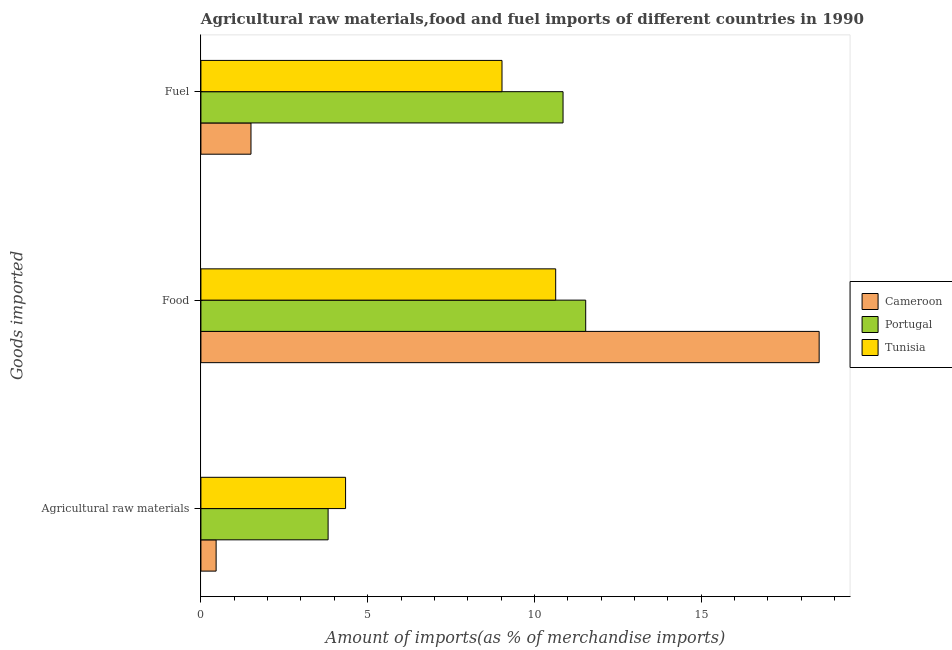How many different coloured bars are there?
Your answer should be very brief. 3. How many bars are there on the 3rd tick from the top?
Give a very brief answer. 3. How many bars are there on the 3rd tick from the bottom?
Keep it short and to the point. 3. What is the label of the 1st group of bars from the top?
Offer a terse response. Fuel. What is the percentage of fuel imports in Tunisia?
Ensure brevity in your answer.  9.03. Across all countries, what is the maximum percentage of food imports?
Make the answer very short. 18.54. Across all countries, what is the minimum percentage of raw materials imports?
Your answer should be very brief. 0.46. In which country was the percentage of raw materials imports maximum?
Your answer should be very brief. Tunisia. In which country was the percentage of raw materials imports minimum?
Provide a short and direct response. Cameroon. What is the total percentage of raw materials imports in the graph?
Your response must be concise. 8.61. What is the difference between the percentage of raw materials imports in Tunisia and that in Cameroon?
Offer a terse response. 3.88. What is the difference between the percentage of food imports in Cameroon and the percentage of fuel imports in Tunisia?
Your answer should be very brief. 9.51. What is the average percentage of fuel imports per country?
Provide a short and direct response. 7.13. What is the difference between the percentage of raw materials imports and percentage of food imports in Cameroon?
Ensure brevity in your answer.  -18.08. What is the ratio of the percentage of raw materials imports in Cameroon to that in Tunisia?
Keep it short and to the point. 0.11. Is the percentage of fuel imports in Portugal less than that in Tunisia?
Provide a succinct answer. No. Is the difference between the percentage of food imports in Portugal and Tunisia greater than the difference between the percentage of raw materials imports in Portugal and Tunisia?
Give a very brief answer. Yes. What is the difference between the highest and the second highest percentage of raw materials imports?
Your answer should be compact. 0.52. What is the difference between the highest and the lowest percentage of food imports?
Make the answer very short. 7.9. In how many countries, is the percentage of food imports greater than the average percentage of food imports taken over all countries?
Offer a very short reply. 1. What does the 2nd bar from the top in Agricultural raw materials represents?
Offer a very short reply. Portugal. What does the 1st bar from the bottom in Food represents?
Offer a very short reply. Cameroon. Is it the case that in every country, the sum of the percentage of raw materials imports and percentage of food imports is greater than the percentage of fuel imports?
Your answer should be very brief. Yes. Are all the bars in the graph horizontal?
Provide a succinct answer. Yes. What is the difference between two consecutive major ticks on the X-axis?
Offer a very short reply. 5. Does the graph contain any zero values?
Make the answer very short. No. Does the graph contain grids?
Offer a terse response. No. How many legend labels are there?
Ensure brevity in your answer.  3. How are the legend labels stacked?
Make the answer very short. Vertical. What is the title of the graph?
Your answer should be compact. Agricultural raw materials,food and fuel imports of different countries in 1990. Does "Rwanda" appear as one of the legend labels in the graph?
Give a very brief answer. No. What is the label or title of the X-axis?
Ensure brevity in your answer.  Amount of imports(as % of merchandise imports). What is the label or title of the Y-axis?
Offer a terse response. Goods imported. What is the Amount of imports(as % of merchandise imports) of Cameroon in Agricultural raw materials?
Your answer should be very brief. 0.46. What is the Amount of imports(as % of merchandise imports) in Portugal in Agricultural raw materials?
Provide a short and direct response. 3.81. What is the Amount of imports(as % of merchandise imports) of Tunisia in Agricultural raw materials?
Offer a very short reply. 4.34. What is the Amount of imports(as % of merchandise imports) of Cameroon in Food?
Keep it short and to the point. 18.54. What is the Amount of imports(as % of merchandise imports) of Portugal in Food?
Give a very brief answer. 11.54. What is the Amount of imports(as % of merchandise imports) of Tunisia in Food?
Offer a very short reply. 10.64. What is the Amount of imports(as % of merchandise imports) of Cameroon in Fuel?
Ensure brevity in your answer.  1.5. What is the Amount of imports(as % of merchandise imports) of Portugal in Fuel?
Keep it short and to the point. 10.86. What is the Amount of imports(as % of merchandise imports) of Tunisia in Fuel?
Make the answer very short. 9.03. Across all Goods imported, what is the maximum Amount of imports(as % of merchandise imports) in Cameroon?
Offer a terse response. 18.54. Across all Goods imported, what is the maximum Amount of imports(as % of merchandise imports) in Portugal?
Provide a succinct answer. 11.54. Across all Goods imported, what is the maximum Amount of imports(as % of merchandise imports) of Tunisia?
Offer a very short reply. 10.64. Across all Goods imported, what is the minimum Amount of imports(as % of merchandise imports) of Cameroon?
Your answer should be very brief. 0.46. Across all Goods imported, what is the minimum Amount of imports(as % of merchandise imports) in Portugal?
Your response must be concise. 3.81. Across all Goods imported, what is the minimum Amount of imports(as % of merchandise imports) in Tunisia?
Ensure brevity in your answer.  4.34. What is the total Amount of imports(as % of merchandise imports) in Cameroon in the graph?
Ensure brevity in your answer.  20.49. What is the total Amount of imports(as % of merchandise imports) in Portugal in the graph?
Make the answer very short. 26.21. What is the total Amount of imports(as % of merchandise imports) of Tunisia in the graph?
Offer a terse response. 24. What is the difference between the Amount of imports(as % of merchandise imports) in Cameroon in Agricultural raw materials and that in Food?
Ensure brevity in your answer.  -18.08. What is the difference between the Amount of imports(as % of merchandise imports) in Portugal in Agricultural raw materials and that in Food?
Provide a short and direct response. -7.72. What is the difference between the Amount of imports(as % of merchandise imports) of Tunisia in Agricultural raw materials and that in Food?
Provide a short and direct response. -6.3. What is the difference between the Amount of imports(as % of merchandise imports) in Cameroon in Agricultural raw materials and that in Fuel?
Provide a short and direct response. -1.05. What is the difference between the Amount of imports(as % of merchandise imports) in Portugal in Agricultural raw materials and that in Fuel?
Your answer should be compact. -7.04. What is the difference between the Amount of imports(as % of merchandise imports) in Tunisia in Agricultural raw materials and that in Fuel?
Your answer should be compact. -4.69. What is the difference between the Amount of imports(as % of merchandise imports) in Cameroon in Food and that in Fuel?
Provide a short and direct response. 17.04. What is the difference between the Amount of imports(as % of merchandise imports) in Portugal in Food and that in Fuel?
Give a very brief answer. 0.68. What is the difference between the Amount of imports(as % of merchandise imports) of Tunisia in Food and that in Fuel?
Provide a succinct answer. 1.61. What is the difference between the Amount of imports(as % of merchandise imports) in Cameroon in Agricultural raw materials and the Amount of imports(as % of merchandise imports) in Portugal in Food?
Your answer should be very brief. -11.08. What is the difference between the Amount of imports(as % of merchandise imports) in Cameroon in Agricultural raw materials and the Amount of imports(as % of merchandise imports) in Tunisia in Food?
Provide a short and direct response. -10.18. What is the difference between the Amount of imports(as % of merchandise imports) of Portugal in Agricultural raw materials and the Amount of imports(as % of merchandise imports) of Tunisia in Food?
Keep it short and to the point. -6.82. What is the difference between the Amount of imports(as % of merchandise imports) in Cameroon in Agricultural raw materials and the Amount of imports(as % of merchandise imports) in Portugal in Fuel?
Offer a terse response. -10.4. What is the difference between the Amount of imports(as % of merchandise imports) of Cameroon in Agricultural raw materials and the Amount of imports(as % of merchandise imports) of Tunisia in Fuel?
Your answer should be compact. -8.57. What is the difference between the Amount of imports(as % of merchandise imports) of Portugal in Agricultural raw materials and the Amount of imports(as % of merchandise imports) of Tunisia in Fuel?
Your answer should be compact. -5.21. What is the difference between the Amount of imports(as % of merchandise imports) of Cameroon in Food and the Amount of imports(as % of merchandise imports) of Portugal in Fuel?
Ensure brevity in your answer.  7.68. What is the difference between the Amount of imports(as % of merchandise imports) of Cameroon in Food and the Amount of imports(as % of merchandise imports) of Tunisia in Fuel?
Provide a short and direct response. 9.51. What is the difference between the Amount of imports(as % of merchandise imports) in Portugal in Food and the Amount of imports(as % of merchandise imports) in Tunisia in Fuel?
Ensure brevity in your answer.  2.51. What is the average Amount of imports(as % of merchandise imports) in Cameroon per Goods imported?
Your response must be concise. 6.83. What is the average Amount of imports(as % of merchandise imports) in Portugal per Goods imported?
Provide a succinct answer. 8.74. What is the average Amount of imports(as % of merchandise imports) of Tunisia per Goods imported?
Your response must be concise. 8. What is the difference between the Amount of imports(as % of merchandise imports) in Cameroon and Amount of imports(as % of merchandise imports) in Portugal in Agricultural raw materials?
Offer a very short reply. -3.36. What is the difference between the Amount of imports(as % of merchandise imports) of Cameroon and Amount of imports(as % of merchandise imports) of Tunisia in Agricultural raw materials?
Give a very brief answer. -3.88. What is the difference between the Amount of imports(as % of merchandise imports) in Portugal and Amount of imports(as % of merchandise imports) in Tunisia in Agricultural raw materials?
Give a very brief answer. -0.52. What is the difference between the Amount of imports(as % of merchandise imports) of Cameroon and Amount of imports(as % of merchandise imports) of Portugal in Food?
Offer a terse response. 7. What is the difference between the Amount of imports(as % of merchandise imports) of Cameroon and Amount of imports(as % of merchandise imports) of Tunisia in Food?
Provide a succinct answer. 7.9. What is the difference between the Amount of imports(as % of merchandise imports) in Cameroon and Amount of imports(as % of merchandise imports) in Portugal in Fuel?
Provide a succinct answer. -9.36. What is the difference between the Amount of imports(as % of merchandise imports) of Cameroon and Amount of imports(as % of merchandise imports) of Tunisia in Fuel?
Provide a short and direct response. -7.53. What is the difference between the Amount of imports(as % of merchandise imports) in Portugal and Amount of imports(as % of merchandise imports) in Tunisia in Fuel?
Your response must be concise. 1.83. What is the ratio of the Amount of imports(as % of merchandise imports) in Cameroon in Agricultural raw materials to that in Food?
Offer a very short reply. 0.02. What is the ratio of the Amount of imports(as % of merchandise imports) in Portugal in Agricultural raw materials to that in Food?
Make the answer very short. 0.33. What is the ratio of the Amount of imports(as % of merchandise imports) of Tunisia in Agricultural raw materials to that in Food?
Keep it short and to the point. 0.41. What is the ratio of the Amount of imports(as % of merchandise imports) in Cameroon in Agricultural raw materials to that in Fuel?
Ensure brevity in your answer.  0.3. What is the ratio of the Amount of imports(as % of merchandise imports) in Portugal in Agricultural raw materials to that in Fuel?
Your response must be concise. 0.35. What is the ratio of the Amount of imports(as % of merchandise imports) of Tunisia in Agricultural raw materials to that in Fuel?
Make the answer very short. 0.48. What is the ratio of the Amount of imports(as % of merchandise imports) in Cameroon in Food to that in Fuel?
Provide a short and direct response. 12.35. What is the ratio of the Amount of imports(as % of merchandise imports) in Portugal in Food to that in Fuel?
Offer a terse response. 1.06. What is the ratio of the Amount of imports(as % of merchandise imports) of Tunisia in Food to that in Fuel?
Make the answer very short. 1.18. What is the difference between the highest and the second highest Amount of imports(as % of merchandise imports) of Cameroon?
Offer a terse response. 17.04. What is the difference between the highest and the second highest Amount of imports(as % of merchandise imports) in Portugal?
Give a very brief answer. 0.68. What is the difference between the highest and the second highest Amount of imports(as % of merchandise imports) of Tunisia?
Give a very brief answer. 1.61. What is the difference between the highest and the lowest Amount of imports(as % of merchandise imports) of Cameroon?
Give a very brief answer. 18.08. What is the difference between the highest and the lowest Amount of imports(as % of merchandise imports) of Portugal?
Ensure brevity in your answer.  7.72. What is the difference between the highest and the lowest Amount of imports(as % of merchandise imports) in Tunisia?
Offer a terse response. 6.3. 